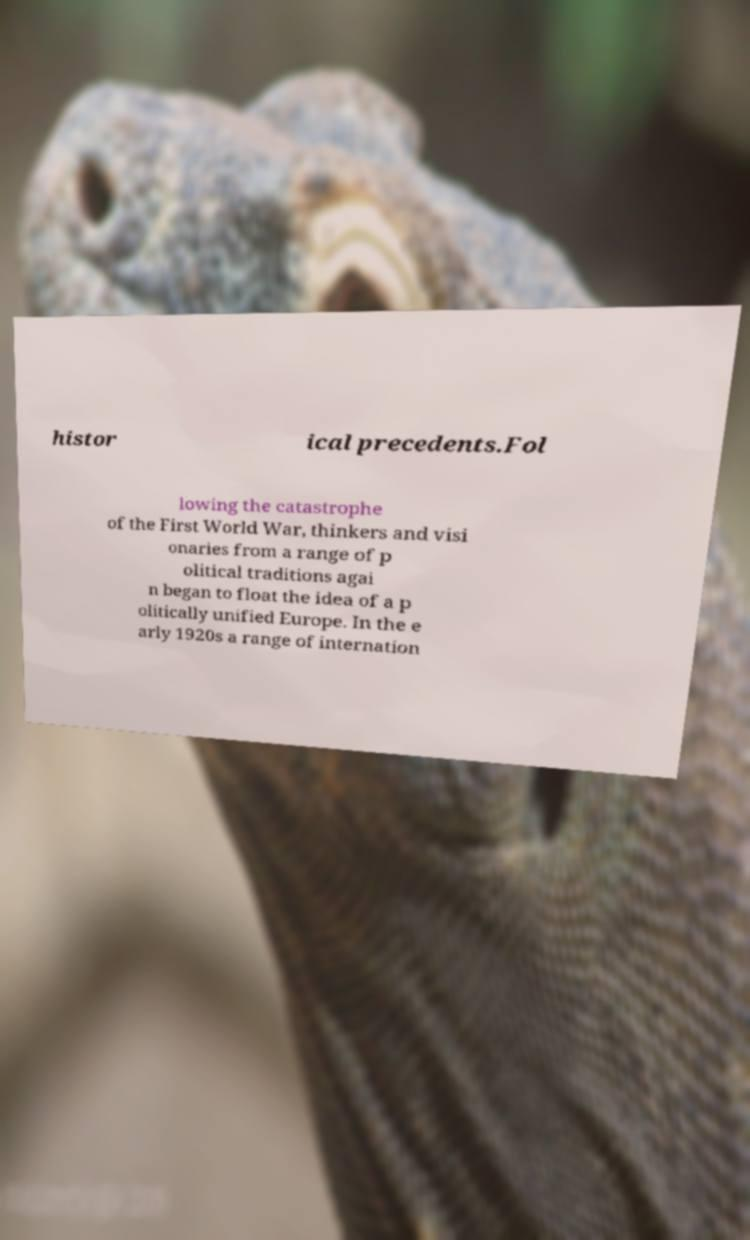Please read and relay the text visible in this image. What does it say? histor ical precedents.Fol lowing the catastrophe of the First World War, thinkers and visi onaries from a range of p olitical traditions agai n began to float the idea of a p olitically unified Europe. In the e arly 1920s a range of internation 